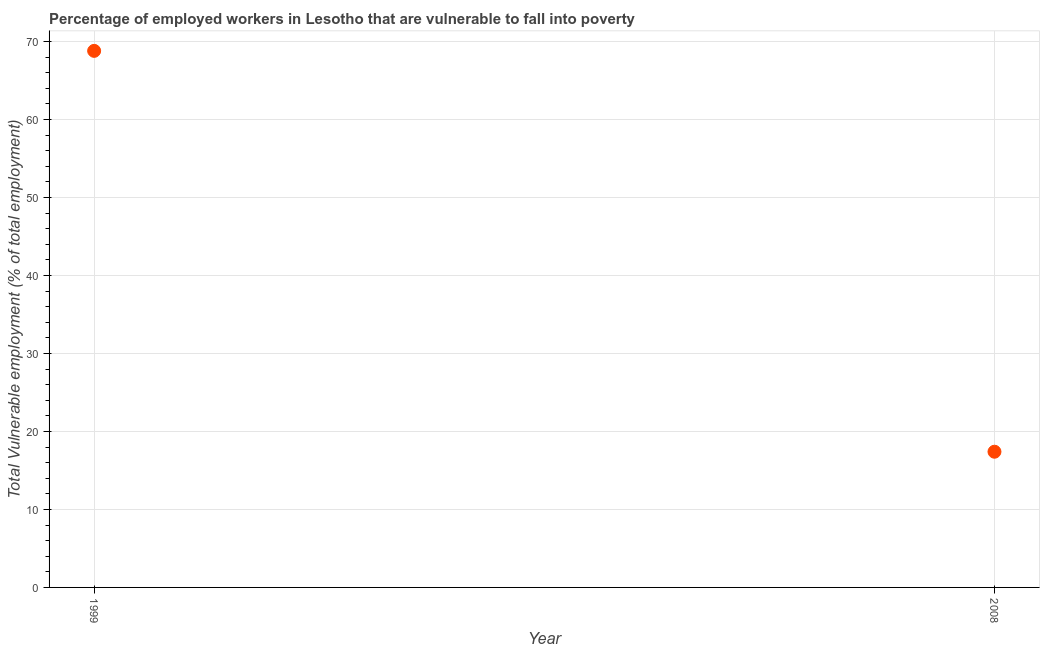What is the total vulnerable employment in 2008?
Make the answer very short. 17.4. Across all years, what is the maximum total vulnerable employment?
Your response must be concise. 68.8. Across all years, what is the minimum total vulnerable employment?
Keep it short and to the point. 17.4. In which year was the total vulnerable employment minimum?
Provide a short and direct response. 2008. What is the sum of the total vulnerable employment?
Keep it short and to the point. 86.2. What is the difference between the total vulnerable employment in 1999 and 2008?
Provide a short and direct response. 51.4. What is the average total vulnerable employment per year?
Keep it short and to the point. 43.1. What is the median total vulnerable employment?
Make the answer very short. 43.1. In how many years, is the total vulnerable employment greater than 50 %?
Your answer should be compact. 1. Do a majority of the years between 1999 and 2008 (inclusive) have total vulnerable employment greater than 12 %?
Your answer should be very brief. Yes. What is the ratio of the total vulnerable employment in 1999 to that in 2008?
Make the answer very short. 3.95. Is the total vulnerable employment in 1999 less than that in 2008?
Your response must be concise. No. In how many years, is the total vulnerable employment greater than the average total vulnerable employment taken over all years?
Offer a terse response. 1. How many years are there in the graph?
Provide a short and direct response. 2. What is the difference between two consecutive major ticks on the Y-axis?
Ensure brevity in your answer.  10. Are the values on the major ticks of Y-axis written in scientific E-notation?
Your answer should be very brief. No. Does the graph contain any zero values?
Your answer should be compact. No. Does the graph contain grids?
Your answer should be compact. Yes. What is the title of the graph?
Give a very brief answer. Percentage of employed workers in Lesotho that are vulnerable to fall into poverty. What is the label or title of the Y-axis?
Make the answer very short. Total Vulnerable employment (% of total employment). What is the Total Vulnerable employment (% of total employment) in 1999?
Keep it short and to the point. 68.8. What is the Total Vulnerable employment (% of total employment) in 2008?
Keep it short and to the point. 17.4. What is the difference between the Total Vulnerable employment (% of total employment) in 1999 and 2008?
Provide a short and direct response. 51.4. What is the ratio of the Total Vulnerable employment (% of total employment) in 1999 to that in 2008?
Provide a short and direct response. 3.95. 